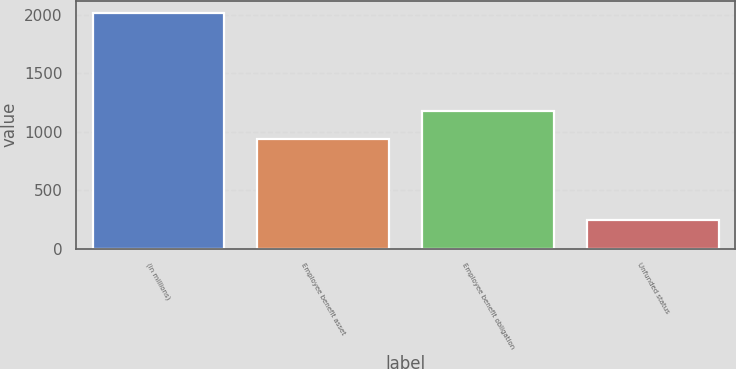Convert chart to OTSL. <chart><loc_0><loc_0><loc_500><loc_500><bar_chart><fcel>(in millions)<fcel>Employee benefit asset<fcel>Employee benefit obligation<fcel>Unfunded status<nl><fcel>2018<fcel>939.3<fcel>1179.9<fcel>240.6<nl></chart> 